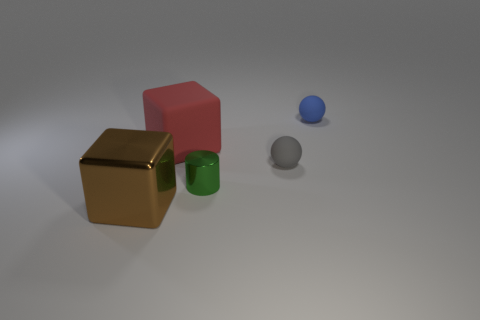Add 4 large cyan metal spheres. How many objects exist? 9 Subtract all cylinders. How many objects are left? 4 Subtract 0 blue cylinders. How many objects are left? 5 Subtract all big red rubber cubes. Subtract all tiny matte things. How many objects are left? 2 Add 3 big rubber cubes. How many big rubber cubes are left? 4 Add 4 gray balls. How many gray balls exist? 5 